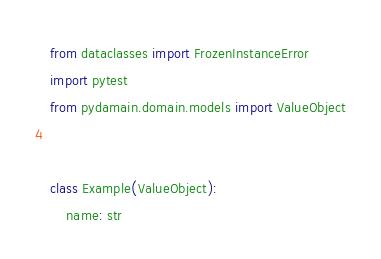Convert code to text. <code><loc_0><loc_0><loc_500><loc_500><_Python_>from dataclasses import FrozenInstanceError
import pytest
from pydamain.domain.models import ValueObject


class Example(ValueObject):
    name: str

</code> 